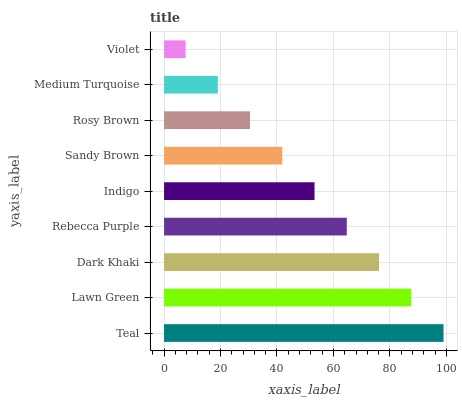Is Violet the minimum?
Answer yes or no. Yes. Is Teal the maximum?
Answer yes or no. Yes. Is Lawn Green the minimum?
Answer yes or no. No. Is Lawn Green the maximum?
Answer yes or no. No. Is Teal greater than Lawn Green?
Answer yes or no. Yes. Is Lawn Green less than Teal?
Answer yes or no. Yes. Is Lawn Green greater than Teal?
Answer yes or no. No. Is Teal less than Lawn Green?
Answer yes or no. No. Is Indigo the high median?
Answer yes or no. Yes. Is Indigo the low median?
Answer yes or no. Yes. Is Medium Turquoise the high median?
Answer yes or no. No. Is Lawn Green the low median?
Answer yes or no. No. 